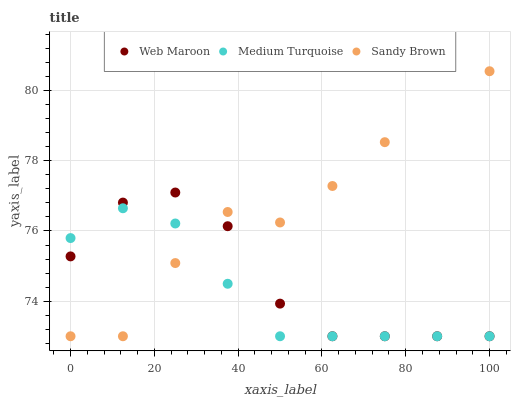Does Medium Turquoise have the minimum area under the curve?
Answer yes or no. Yes. Does Sandy Brown have the maximum area under the curve?
Answer yes or no. Yes. Does Web Maroon have the minimum area under the curve?
Answer yes or no. No. Does Web Maroon have the maximum area under the curve?
Answer yes or no. No. Is Medium Turquoise the smoothest?
Answer yes or no. Yes. Is Sandy Brown the roughest?
Answer yes or no. Yes. Is Web Maroon the smoothest?
Answer yes or no. No. Is Web Maroon the roughest?
Answer yes or no. No. Does Sandy Brown have the lowest value?
Answer yes or no. Yes. Does Sandy Brown have the highest value?
Answer yes or no. Yes. Does Web Maroon have the highest value?
Answer yes or no. No. Does Sandy Brown intersect Web Maroon?
Answer yes or no. Yes. Is Sandy Brown less than Web Maroon?
Answer yes or no. No. Is Sandy Brown greater than Web Maroon?
Answer yes or no. No. 